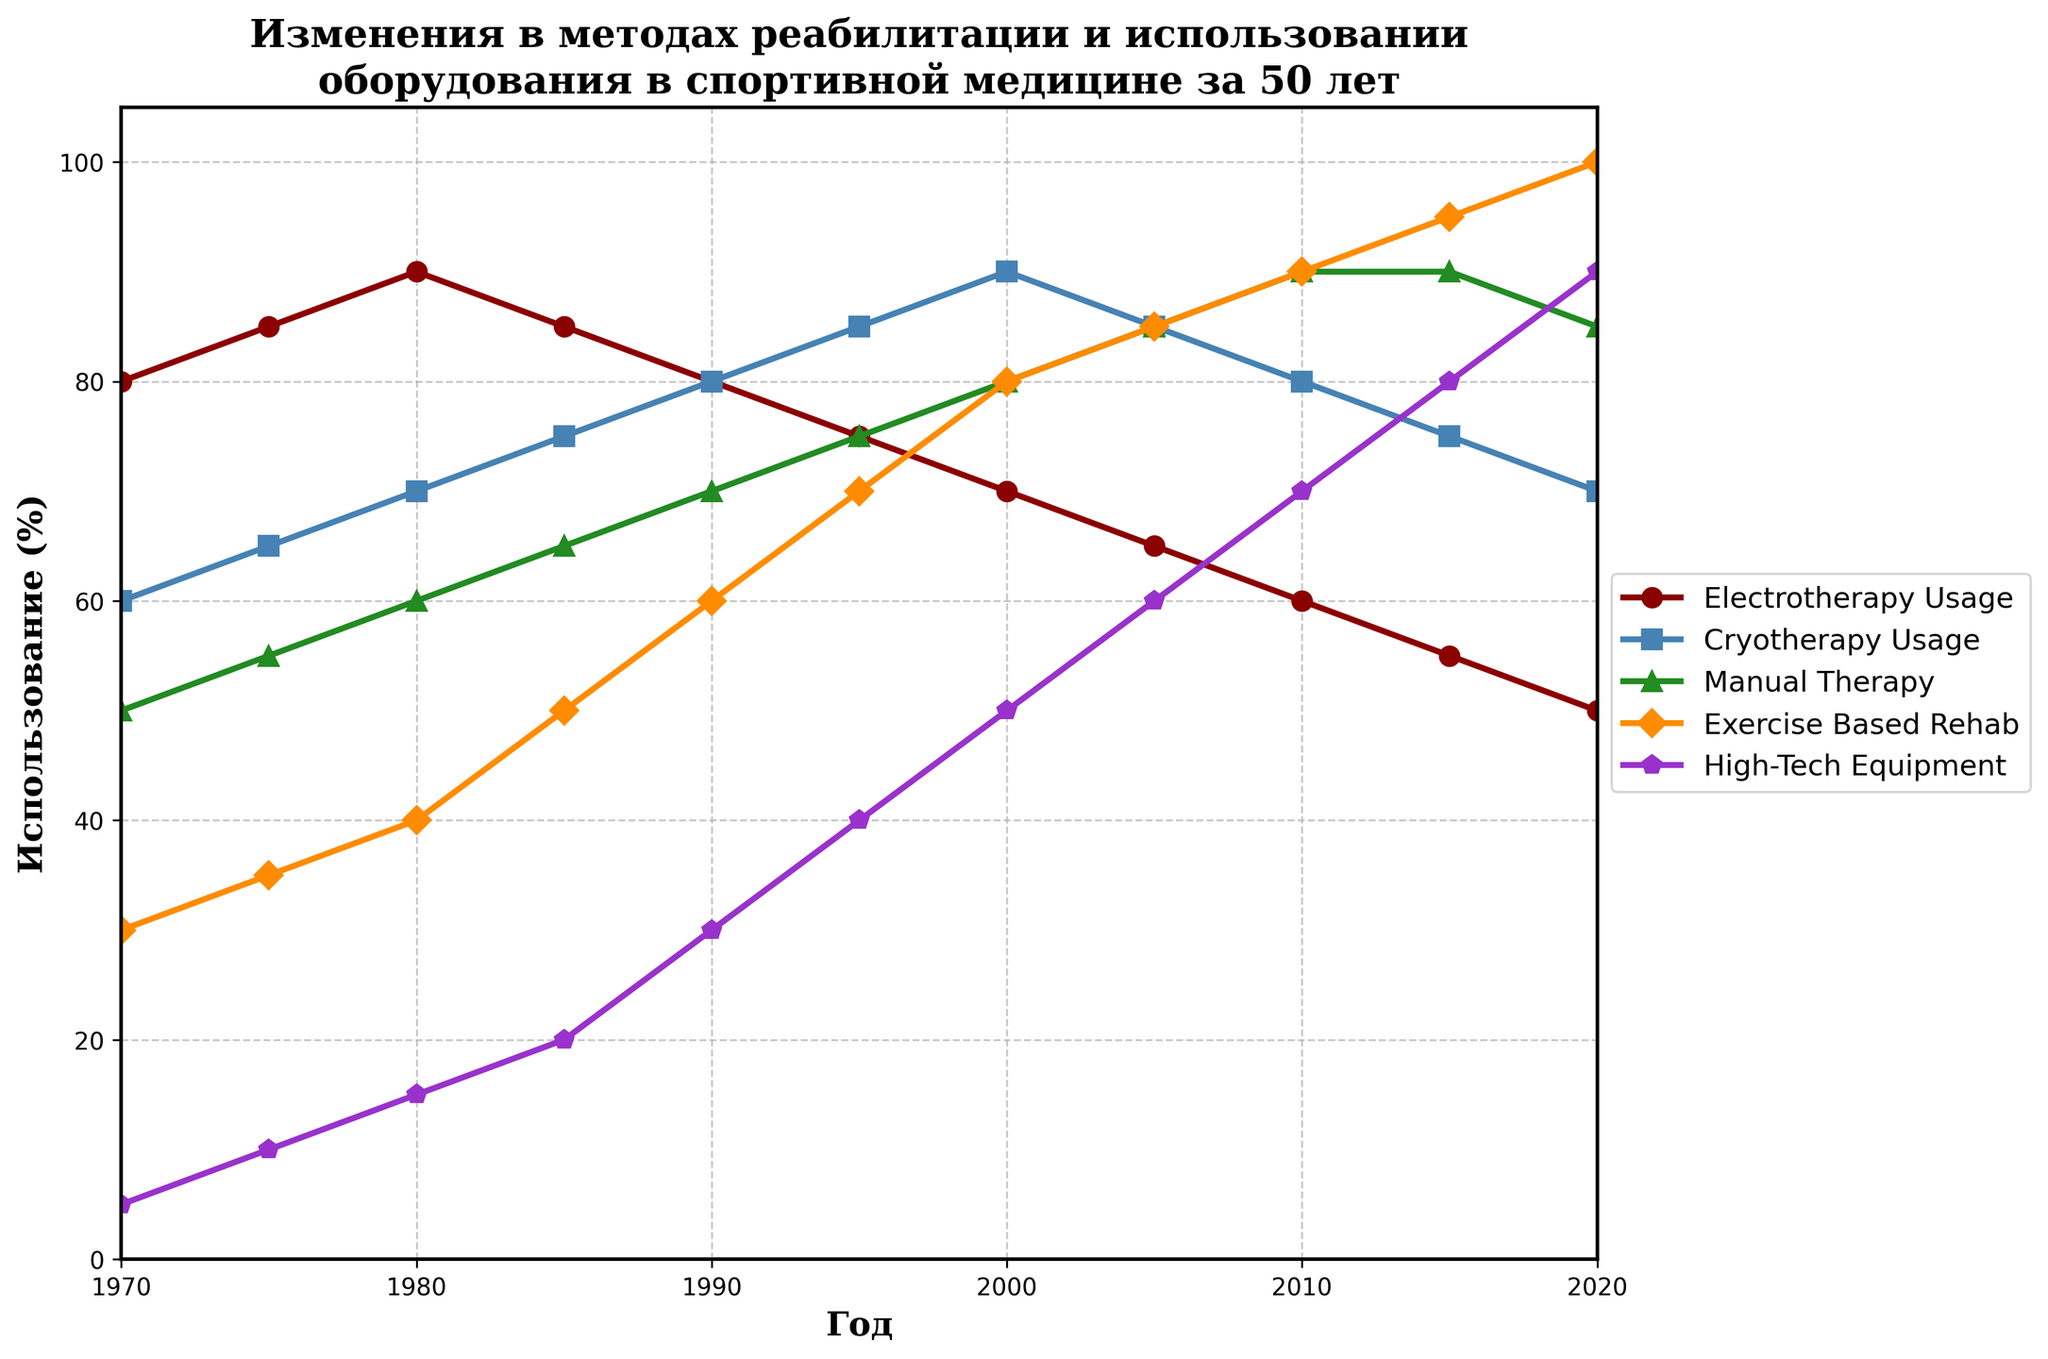Which rehabilitation technique saw the most significant increase in usage from 1970 to 2020? First, find the usage percentage for each technique in 1970 and 2020. Then, calculate the increase for each technique by subtracting the 1970 value from the 2020 value. The values are as follows: Electrotherapy (80-50=30), Cryotherapy (60-70=10), Manual Therapy (50-85=35), Exercise-Based Rehab (30-100=70), High-Tech Equipment (5-90=85). Exercise-Based Rehab increased the most by 70%.
Answer: Exercise-Based Rehab How does the usage of Manual Therapy in 2000 compare to its usage in 1980? Locate the usage percentage of Manual Therapy for both 1980 and 2000 on the chart. The values are 60% in 1980 and 80% in 2000. Compare these values, showing that the usage increased from 60% to 80%.
Answer: Increased Which technique had a consistent upward trend in usage from 1970 to 2020 without any decline? Inspect the lines representing each technique over the years. Manual Therapy (50 to 90), Exercise-Based Rehab (30 to 100), and High-Tech Equipment (5 to 90) all show increases year by year without any decline.
Answer: Exercise-Based Rehab In which year did Cryotherapy and Manual Therapy have the same usage percentage? Identify the years where the lines for Cryotherapy and Manual Therapy intersect on the chart. They intersect around the year 2010, where the usage is approximately 80% for both techniques.
Answer: 2010 What is the average usage percentage of High-Tech Equipment between 2000 and 2020? Sum the usage percentages of High-Tech Equipment from 2000 to 2020: 50 (2000), 60 (2005), 70 (2010), 80 (2015), and 90 (2020). Then divide the sum by the number of years (5): (50 + 60 + 70 + 80 + 90) / 5 = 350 / 5 = 70%.
Answer: 70% Which rehabilitation technique saw a decline in usage after reaching its peak in 1980? Identify the peak year usage for each technique and check if their usage declined afterward. Electrotherapy's usage peaked at 90% in 1980 and then declined to 50% in 2020.
Answer: Electrotherapy Between 1970 and 2020, which technique had the smallest overall change in usage? Calculate the change in usage from 1970 to 2020 for each technique. The changes are: Electrotherapy (80-50=30), Cryotherapy (70-60=10), Manual Therapy (90-50=40), Exercise-Based Rehab (100-30=70), and High-Tech Equipment (90-5=85). Cryotherapy changed the least by 10%.
Answer: Cryotherapy Which two techniques had equal usage in 2005? Locate the usage percentages for each technique in 2005. Both Manual Therapy and Exercise-Based Rehab had a usage percentage of 85% in 2005.
Answer: Manual Therapy and Exercise-Based Rehab How does the trend in Exercise-Based Rehab from 1970 to 2020 compare with the trend in Electrotherapy usage over the same period? Exercise-Based Rehab shows a consistent upward trend from 30% in 1970 to 100% in 2020. Electrotherapy shows an initial increase until 1980, reaching 90%, then a decline to 50% in 2020. The trends are opposite; one consistently increases while the other initially increases and then decreases.
Answer: Opposite trends 